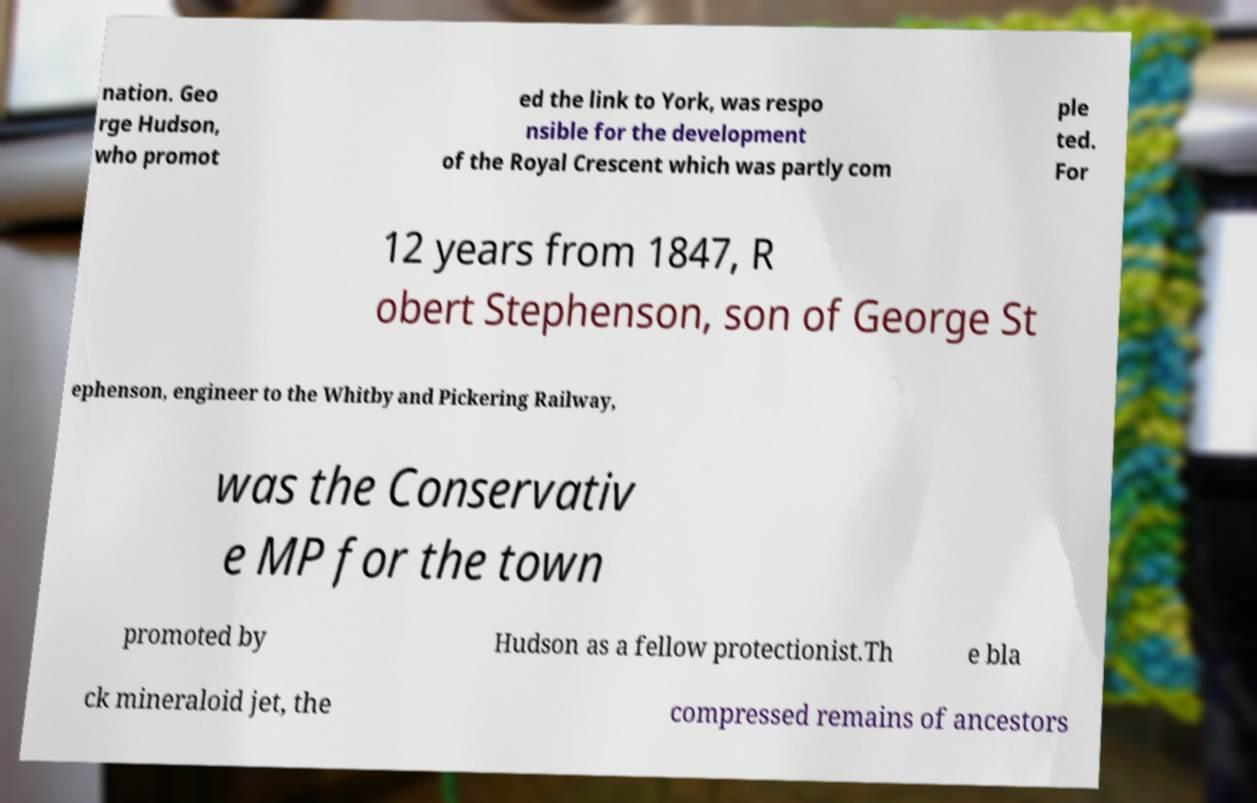For documentation purposes, I need the text within this image transcribed. Could you provide that? nation. Geo rge Hudson, who promot ed the link to York, was respo nsible for the development of the Royal Crescent which was partly com ple ted. For 12 years from 1847, R obert Stephenson, son of George St ephenson, engineer to the Whitby and Pickering Railway, was the Conservativ e MP for the town promoted by Hudson as a fellow protectionist.Th e bla ck mineraloid jet, the compressed remains of ancestors 